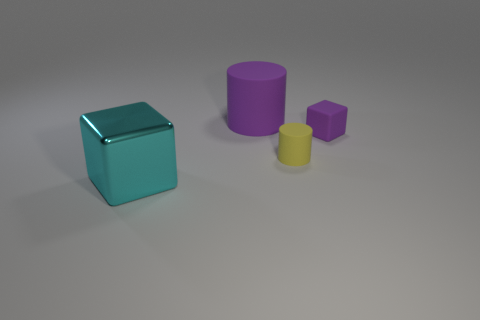There is another rubber object that is the same color as the big matte thing; what shape is it?
Your answer should be compact. Cube. What material is the tiny purple cube?
Keep it short and to the point. Rubber. There is a cube right of the large cube; what size is it?
Your answer should be very brief. Small. How many other large purple rubber objects are the same shape as the big purple object?
Provide a short and direct response. 0. There is a purple object that is made of the same material as the big cylinder; what shape is it?
Ensure brevity in your answer.  Cube. How many purple things are tiny cubes or big things?
Offer a terse response. 2. There is a large purple matte object; are there any small purple objects left of it?
Offer a very short reply. No. Does the big object to the right of the cyan metallic cube have the same shape as the tiny object that is to the right of the yellow rubber cylinder?
Your answer should be compact. No. There is another yellow object that is the same shape as the large rubber object; what is its material?
Offer a very short reply. Rubber. How many cylinders are either big cyan objects or big yellow objects?
Give a very brief answer. 0. 